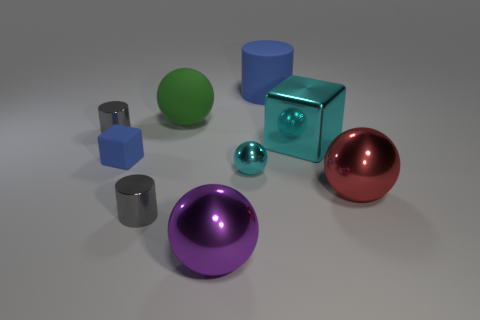Subtract all large rubber cylinders. How many cylinders are left? 2 Subtract all blue cubes. How many cubes are left? 1 Add 1 tiny cylinders. How many objects exist? 10 Subtract 2 cubes. How many cubes are left? 0 Subtract all blocks. How many objects are left? 7 Subtract 0 brown cubes. How many objects are left? 9 Subtract all gray blocks. Subtract all blue cylinders. How many blocks are left? 2 Subtract all red blocks. How many gray cylinders are left? 2 Subtract all purple balls. Subtract all big green rubber balls. How many objects are left? 7 Add 7 blue rubber cylinders. How many blue rubber cylinders are left? 8 